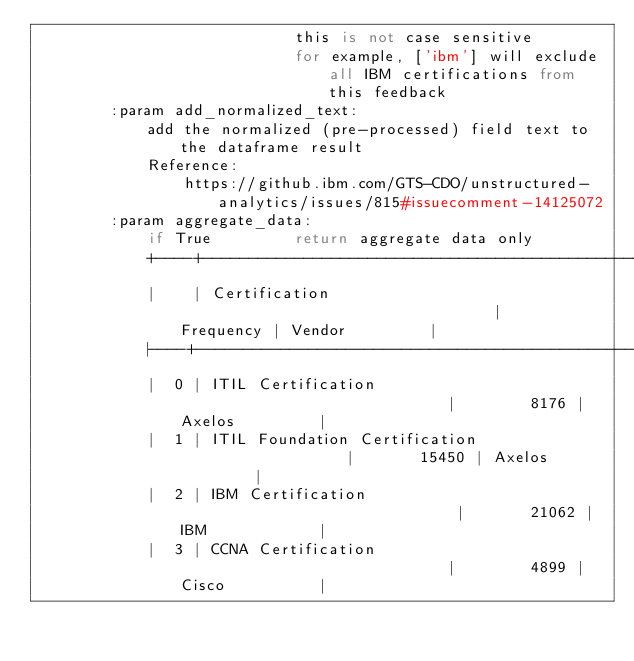<code> <loc_0><loc_0><loc_500><loc_500><_Python_>                            this is not case sensitive
                            for example, ['ibm'] will exclude all IBM certifications from this feedback
        :param add_normalized_text:
            add the normalized (pre-processed) field text to the dataframe result
            Reference:
                https://github.ibm.com/GTS-CDO/unstructured-analytics/issues/815#issuecomment-14125072
        :param aggregate_data:
            if True         return aggregate data only
            +----+-------------------------------------------------+-------------+----------------+
            |    | Certification                                   |   Frequency | Vendor         |
            |----+-------------------------------------------------+-------------+----------------|
            |  0 | ITIL Certification                              |        8176 | Axelos         |
            |  1 | ITIL Foundation Certification                   |       15450 | Axelos         |
            |  2 | IBM Certification                               |       21062 | IBM            |
            |  3 | CCNA Certification                              |        4899 | Cisco          |</code> 